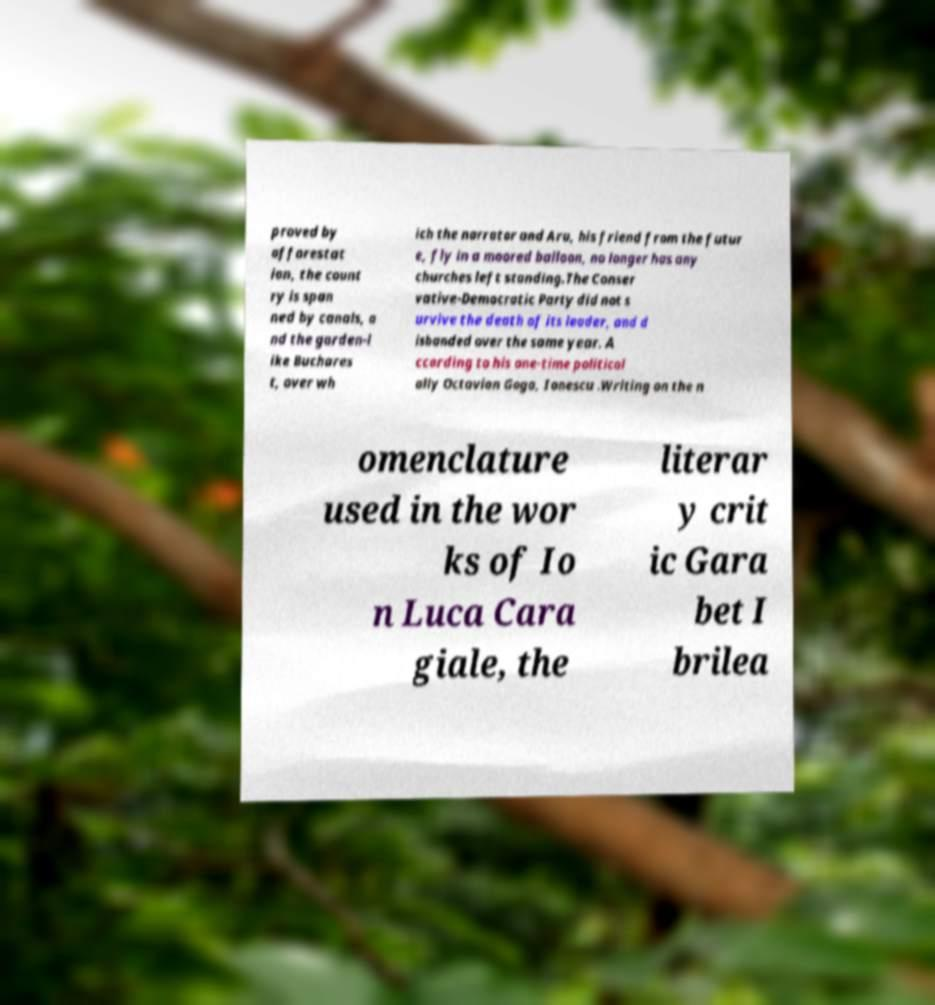Can you read and provide the text displayed in the image?This photo seems to have some interesting text. Can you extract and type it out for me? proved by afforestat ion, the count ry is span ned by canals, a nd the garden-l ike Buchares t, over wh ich the narrator and Aru, his friend from the futur e, fly in a moored balloon, no longer has any churches left standing.The Conser vative-Democratic Party did not s urvive the death of its leader, and d isbanded over the same year. A ccording to his one-time political ally Octavian Goga, Ionescu .Writing on the n omenclature used in the wor ks of Io n Luca Cara giale, the literar y crit ic Gara bet I brilea 